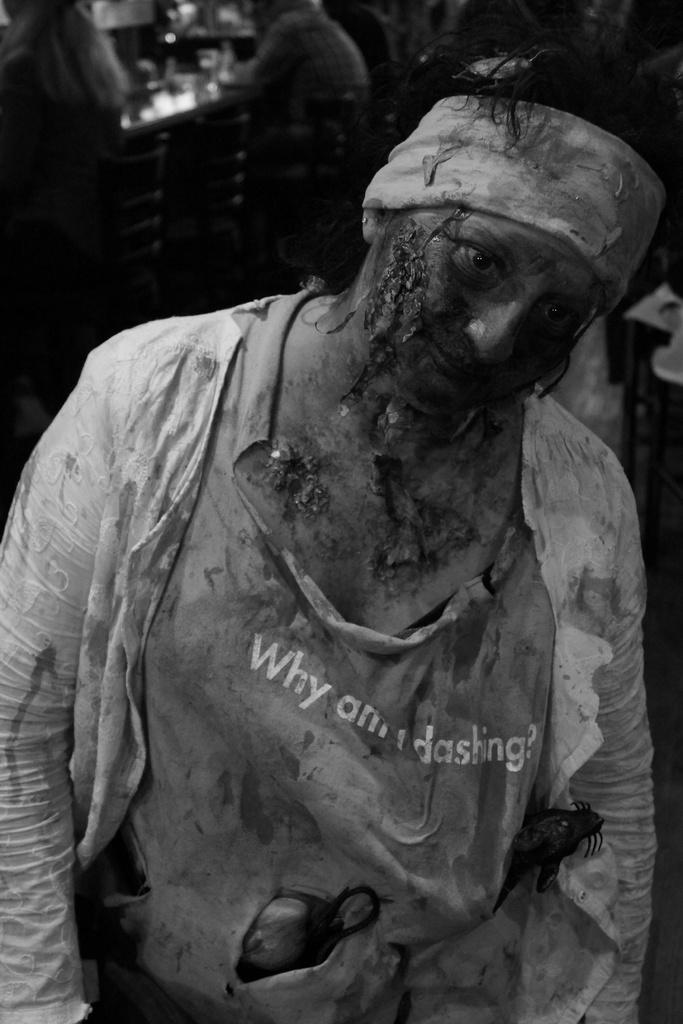What is the color scheme of the image? The image is black and white. What is the condition of the person in the image? There is an injured person in the image. What type of clothing is the injured person wearing? The injured person is wearing a t-shirt, a jacket, and a headband. Are there any other people visible in the image? Yes, there are other people visible in the background of the image. How many pickles are on the chair in the image? There are no chairs or pickles present in the image. What type of care is being provided to the injured person in the image? The image does not show any specific care being provided to the injured person; it only shows their appearance and the presence of other people in the background. 